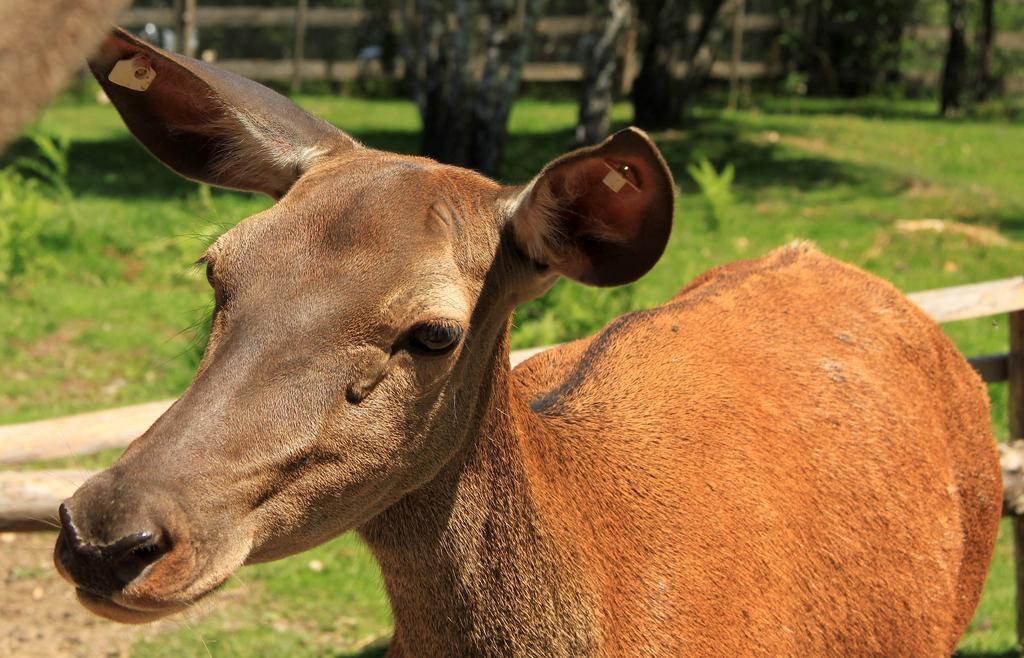Describe this image in one or two sentences. In this image I can see a animal which is brown in color is standing on the ground and I can see two badges to its ears. In the background I can see the fencing, the grass, few plants and few trees. 